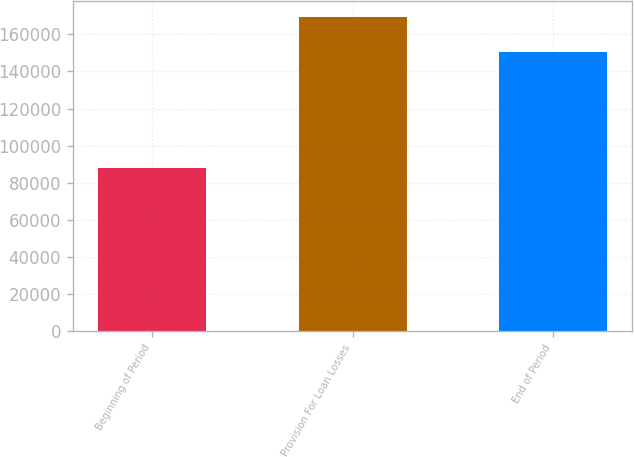<chart> <loc_0><loc_0><loc_500><loc_500><bar_chart><fcel>Beginning of Period<fcel>Provision For Loan Losses<fcel>End of Period<nl><fcel>88155<fcel>169341<fcel>150272<nl></chart> 